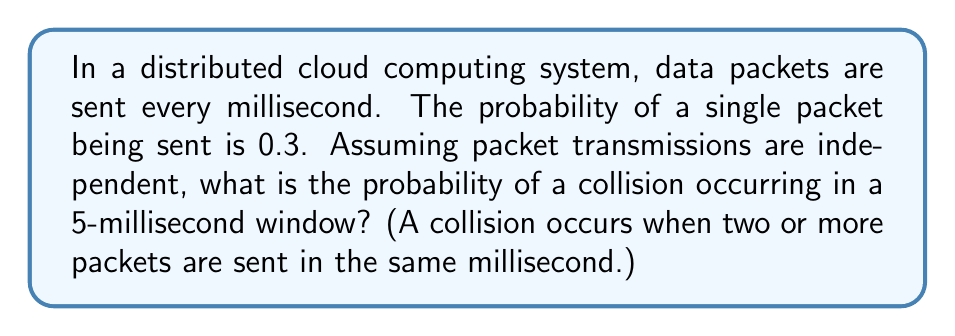Show me your answer to this math problem. Let's approach this step-by-step:

1) First, we need to find the probability of no collision in a single millisecond. This is equivalent to the probability of either 0 or 1 packet being sent.

   $P(\text{no collision in 1 ms}) = P(0 \text{ packets}) + P(1 \text{ packet})$

2) The number of packets sent in a millisecond follows a binomial distribution with $n=1$ and $p=0.3$. So:

   $P(0 \text{ packets}) = (1-0.3)^1 = 0.7$
   $P(1 \text{ packet}) = \binom{1}{1} 0.3^1 (1-0.3)^0 = 0.3$

3) Therefore:

   $P(\text{no collision in 1 ms}) = 0.7 + 0.3 = 1$

4) For a collision to not occur in 5 milliseconds, there must be no collision in each of the 5 milliseconds. Since the events are independent:

   $P(\text{no collision in 5 ms}) = (1)^5 = 1$

5) The probability of a collision occurring is the complement of this:

   $P(\text{collision in 5 ms}) = 1 - P(\text{no collision in 5 ms}) = 1 - 1 = 0$

This result might seem counterintuitive, but it's correct given the assumptions of the problem. In this model, at most one packet can be sent per millisecond, so collisions are impossible.
Answer: The probability of a collision occurring in a 5-millisecond window is 0. 